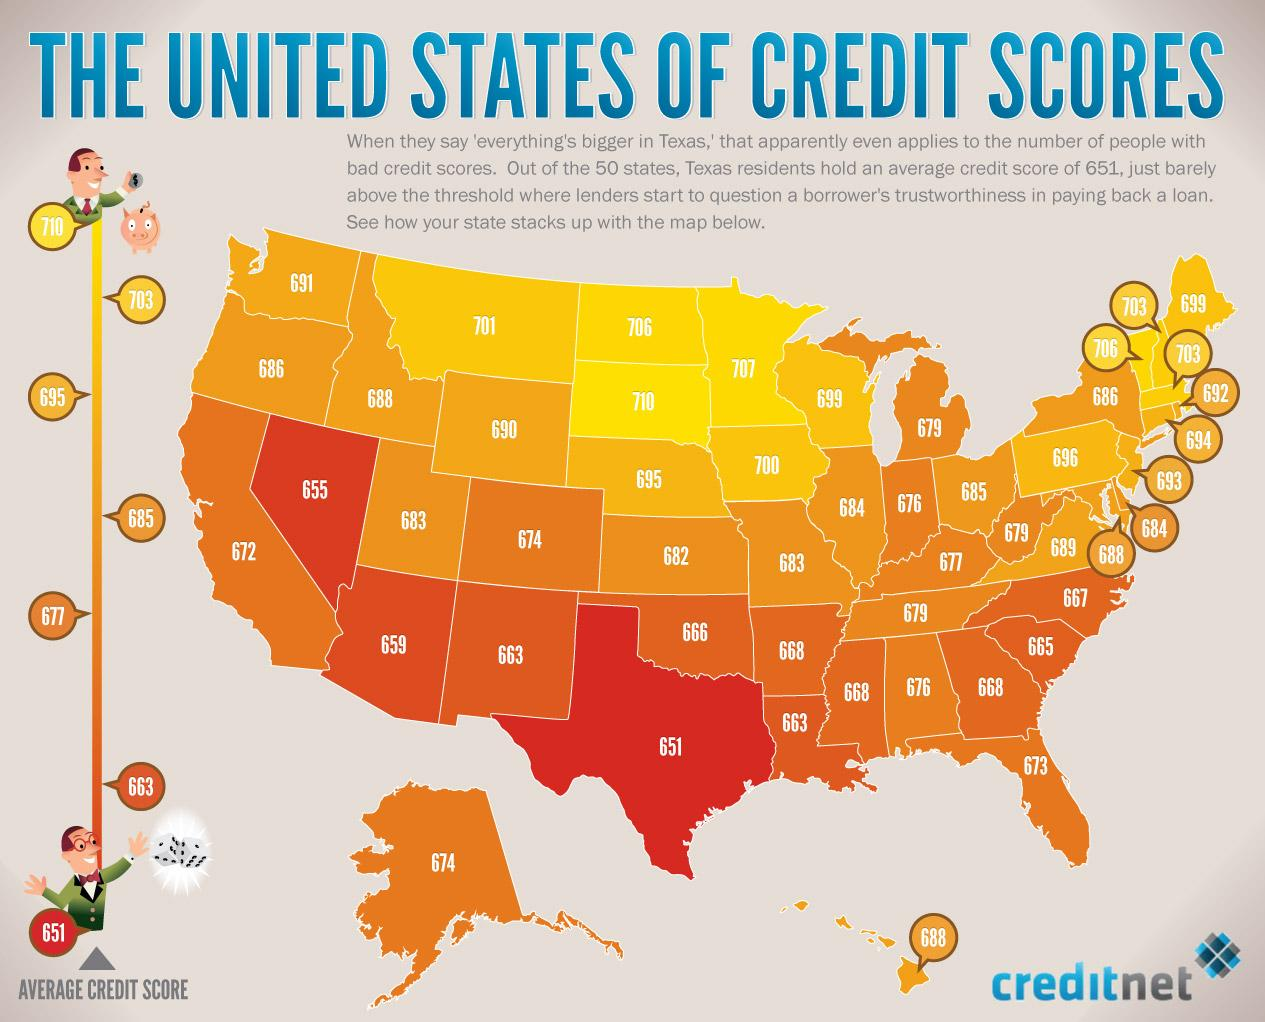Draw attention to some important aspects in this diagram. Eight states have credit scores above 700. The second highest credit score is 707. The states in which region have comparatively better credit scores are primarily located in the northern regions of the United States. The second lowest credit score, according to the image provided, is 655. 